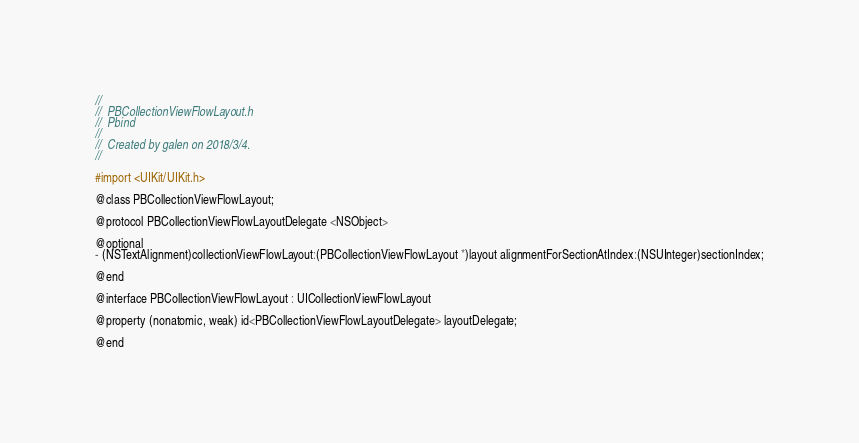Convert code to text. <code><loc_0><loc_0><loc_500><loc_500><_C_>//
//  PBCollectionViewFlowLayout.h
//  Pbind
//
//  Created by galen on 2018/3/4.
//

#import <UIKit/UIKit.h>

@class PBCollectionViewFlowLayout;

@protocol PBCollectionViewFlowLayoutDelegate <NSObject>

@optional
- (NSTextAlignment)collectionViewFlowLayout:(PBCollectionViewFlowLayout *)layout alignmentForSectionAtIndex:(NSUInteger)sectionIndex;

@end

@interface PBCollectionViewFlowLayout : UICollectionViewFlowLayout

@property (nonatomic, weak) id<PBCollectionViewFlowLayoutDelegate> layoutDelegate;

@end
</code> 